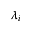<formula> <loc_0><loc_0><loc_500><loc_500>\lambda _ { i }</formula> 